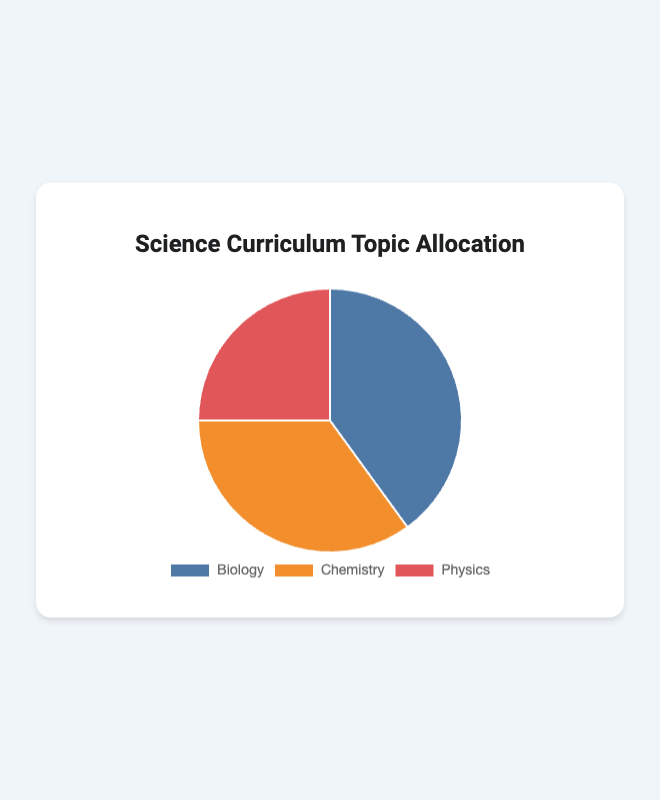What percentage of the science curriculum is allocated to Physics? Looking at the figure, we see that the pie chart shows Physics is allocated 25% of the science curriculum.
Answer: 25% Which subject has the highest allocation in the science curriculum? Observing the pie chart, Biology has the largest portion, covering 40% of the science curriculum.
Answer: Biology How much greater is the allocation for Biology compared to Physics? The allocation for Biology is 40% and for Physics is 25%. The difference is 40% - 25% = 15%.
Answer: 15% What is the total percentage of the curriculum allocated to Chemistry and Physics combined? Adding the percentages for Chemistry (35%) and Physics (25%) gives us 35% + 25% = 60%.
Answer: 60% If we need to increase Physics allocation to equal Chemistry, what would be the new allocation percentage for Physics? Currently, Physics is 25% and Chemistry is 35%. To make Physics equal Chemistry, increase Physics by 35% - 25% = 10%. So, the new allocation for Physics would be 25% + 10% = 35%.
Answer: 35% Is the allocation for Chemistry closer to the allocation for Biology or Physics? Chemistry is 35%, Biology is 40%, and Physics is 25%. The difference between Chemistry and Biology is 40% - 35% = 5%, and between Chemistry and Physics is 35% - 25% = 10%. Since 5% < 10%, Chemistry is closer to Biology than Physics.
Answer: Biology What is the average allocation percentage across the three subjects? To find the average, add all three allocations together and divide by 3: (40% + 35% + 25%) / 3 = 100% / 3 ≈ 33.33%.
Answer: 33.33% What color represents Biology in the pie chart? Looking at the visual attributes of the pie chart, Biology is represented by the blue section.
Answer: Blue If we redistribute 5% from Biology to Physics, what would be the new allocation for Physics? Current allocation for Physics is 25%. Adding 5% from Biology, the new allocation would be 25% + 5% = 30%.
Answer: 30% What is the smallest segment in the pie chart, and what is its percentage? Observing the pie chart, Physics is the smallest segment with an allocation of 25%.
Answer: Physics, 25% 